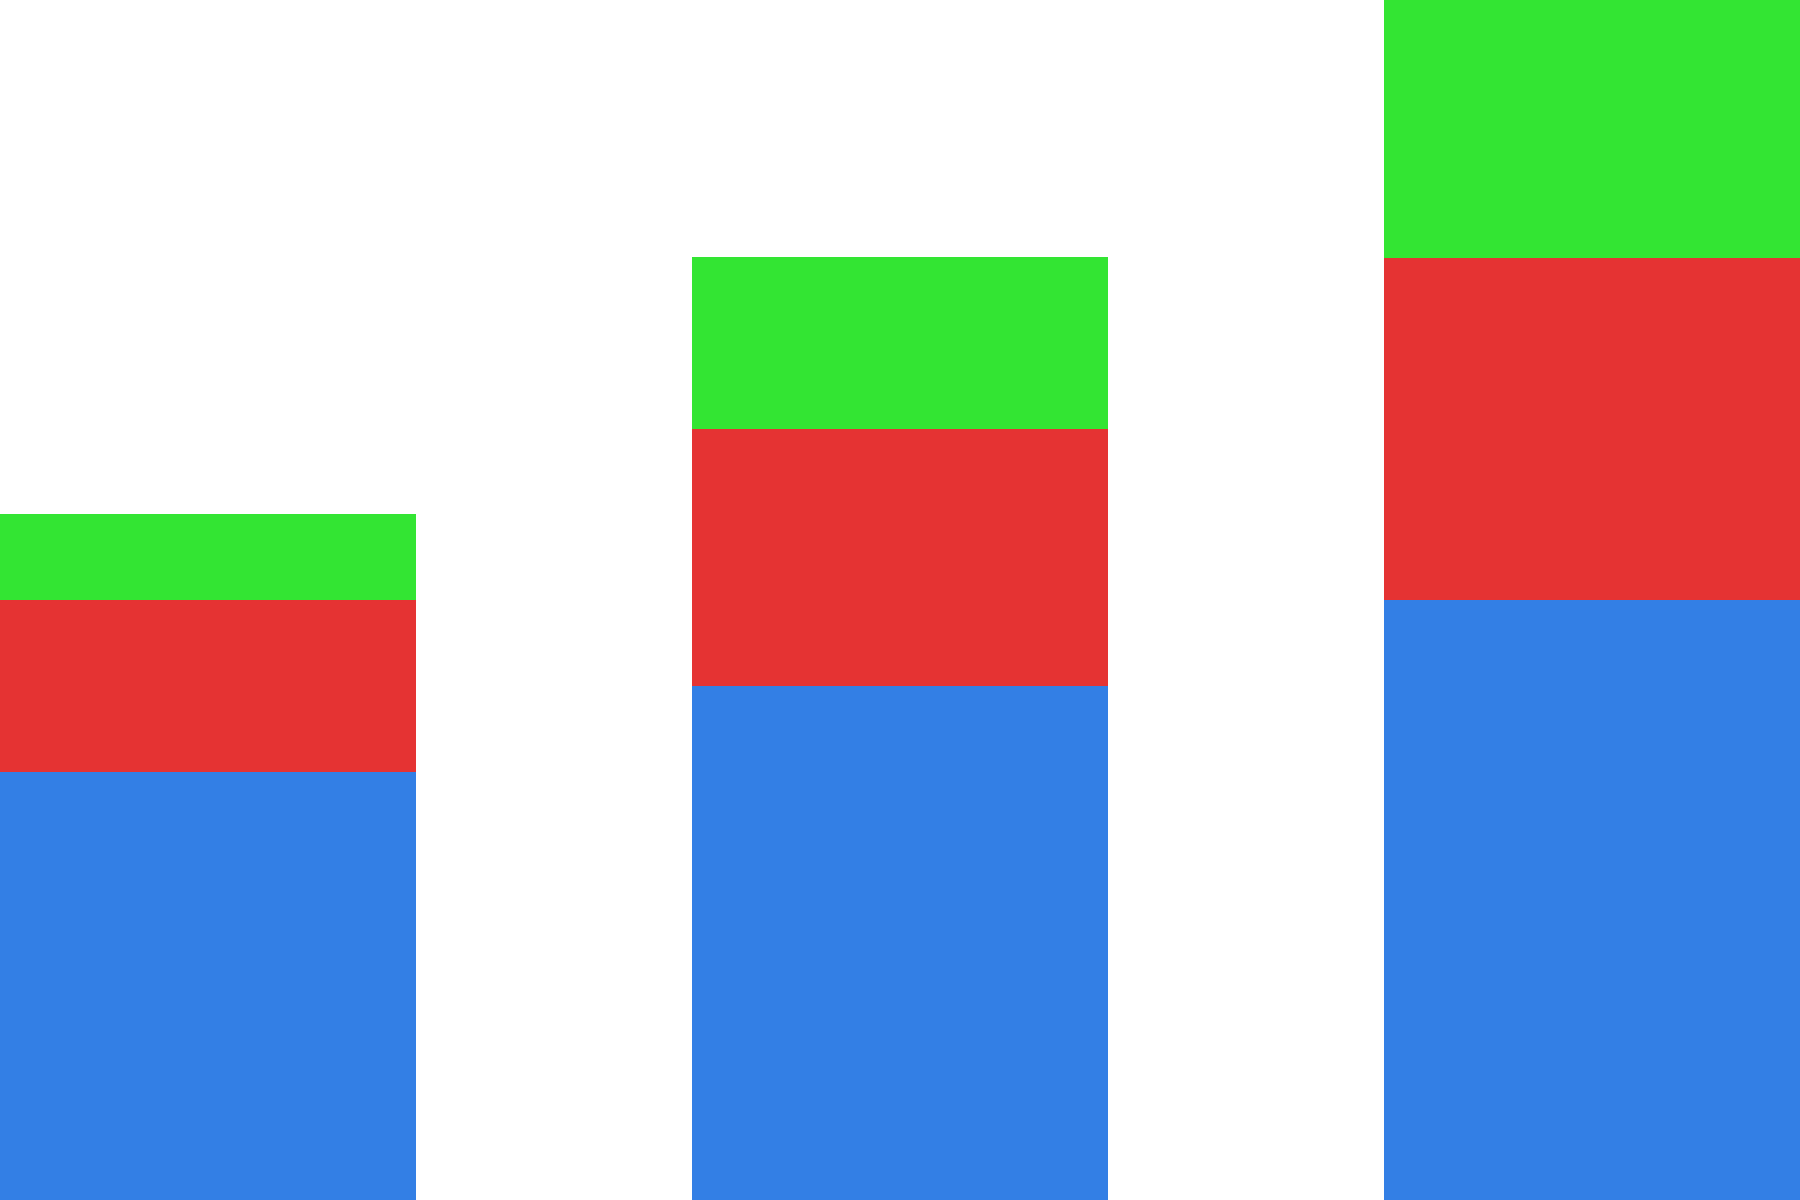Analyze the stacked bar chart depicting the representation of women in three major Irish political parties from 2000 to 2020. Which party demonstrated the most significant increase in women's representation, and by how many percentage points did it grow over the 20-year period? To determine which party had the largest increase in women's representation and by how many percentage points, we need to:

1. Identify the percentage for each party in 2000 and 2020.
2. Calculate the increase for each party.
3. Compare the increases to find the largest.

Fine Gael:
2000: 25%
2020: 35%
Increase: 35% - 25% = 10 percentage points

Fianna Fáil:
2000: 10%
2020: 20%
Increase: 20% - 10% = 10 percentage points

Labour:
2000: 5%
2020: 15%
Increase: 15% - 5% = 10 percentage points

All three parties show an equal increase of 10 percentage points. However, the question asks for the "most significant increase," which can be interpreted as the largest relative increase.

To calculate the relative increase:
Fine Gael: (35% - 25%) / 25% = 40% increase
Fianna Fáil: (20% - 10%) / 10% = 100% increase
Labour: (15% - 5%) / 5% = 200% increase

Therefore, Labour demonstrated the most significant increase in women's representation, growing by 10 percentage points, which represents a 200% relative increase over the 20-year period.
Answer: Labour, 10 percentage points (200% relative increase) 